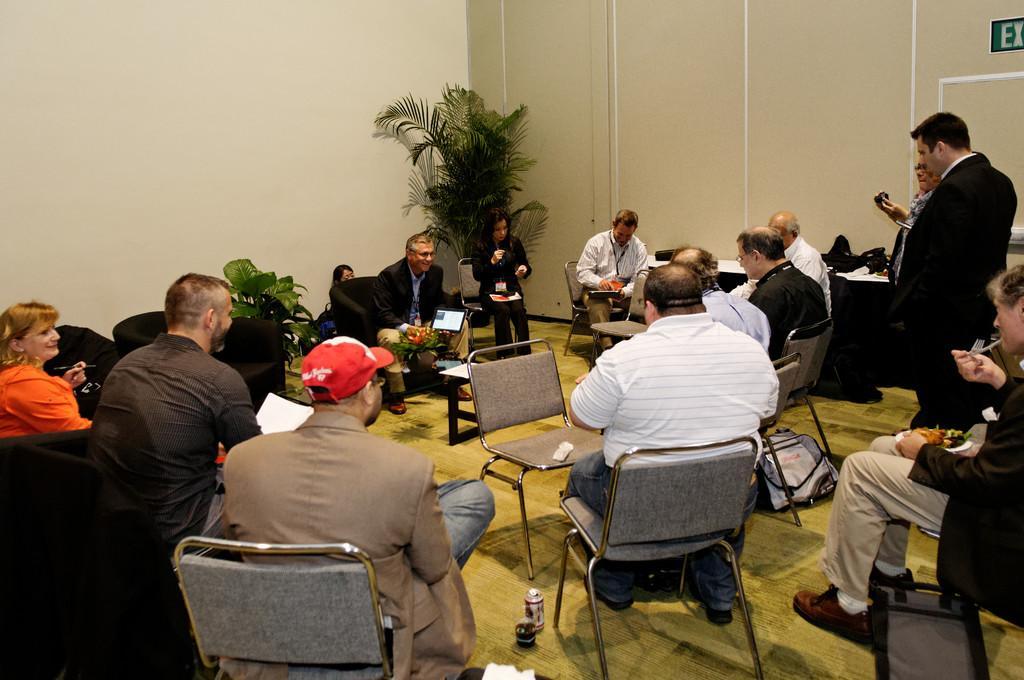Can you describe this image briefly? This image is clicked in a room. There are so many chairs in the room. There are so many people sitting on the chairs. There is woman on the left side. There is a bottle and glass on the floor. There is a shrub. There is person in the middle of the room who is sitting and smiling and holding an ipad. There is exit board. There are two people standing on right side corner. And on the right side middle of the room a person is sitting and he is eating something. In the middle of the room under the chair there is a bag. 